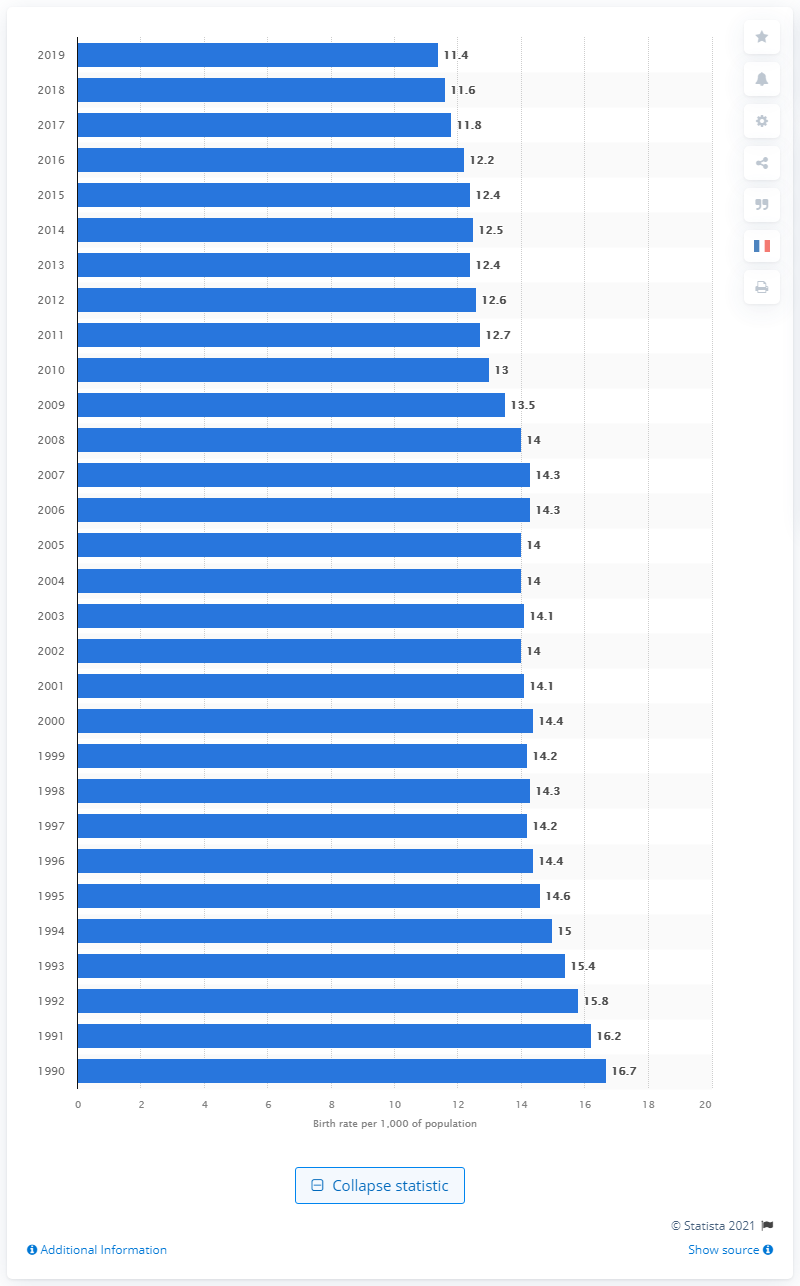Highlight a few significant elements in this photo. The birth rate per 1,000 of the population in 2019 was 11.4. In 1990, the birth rate was 16.7. 